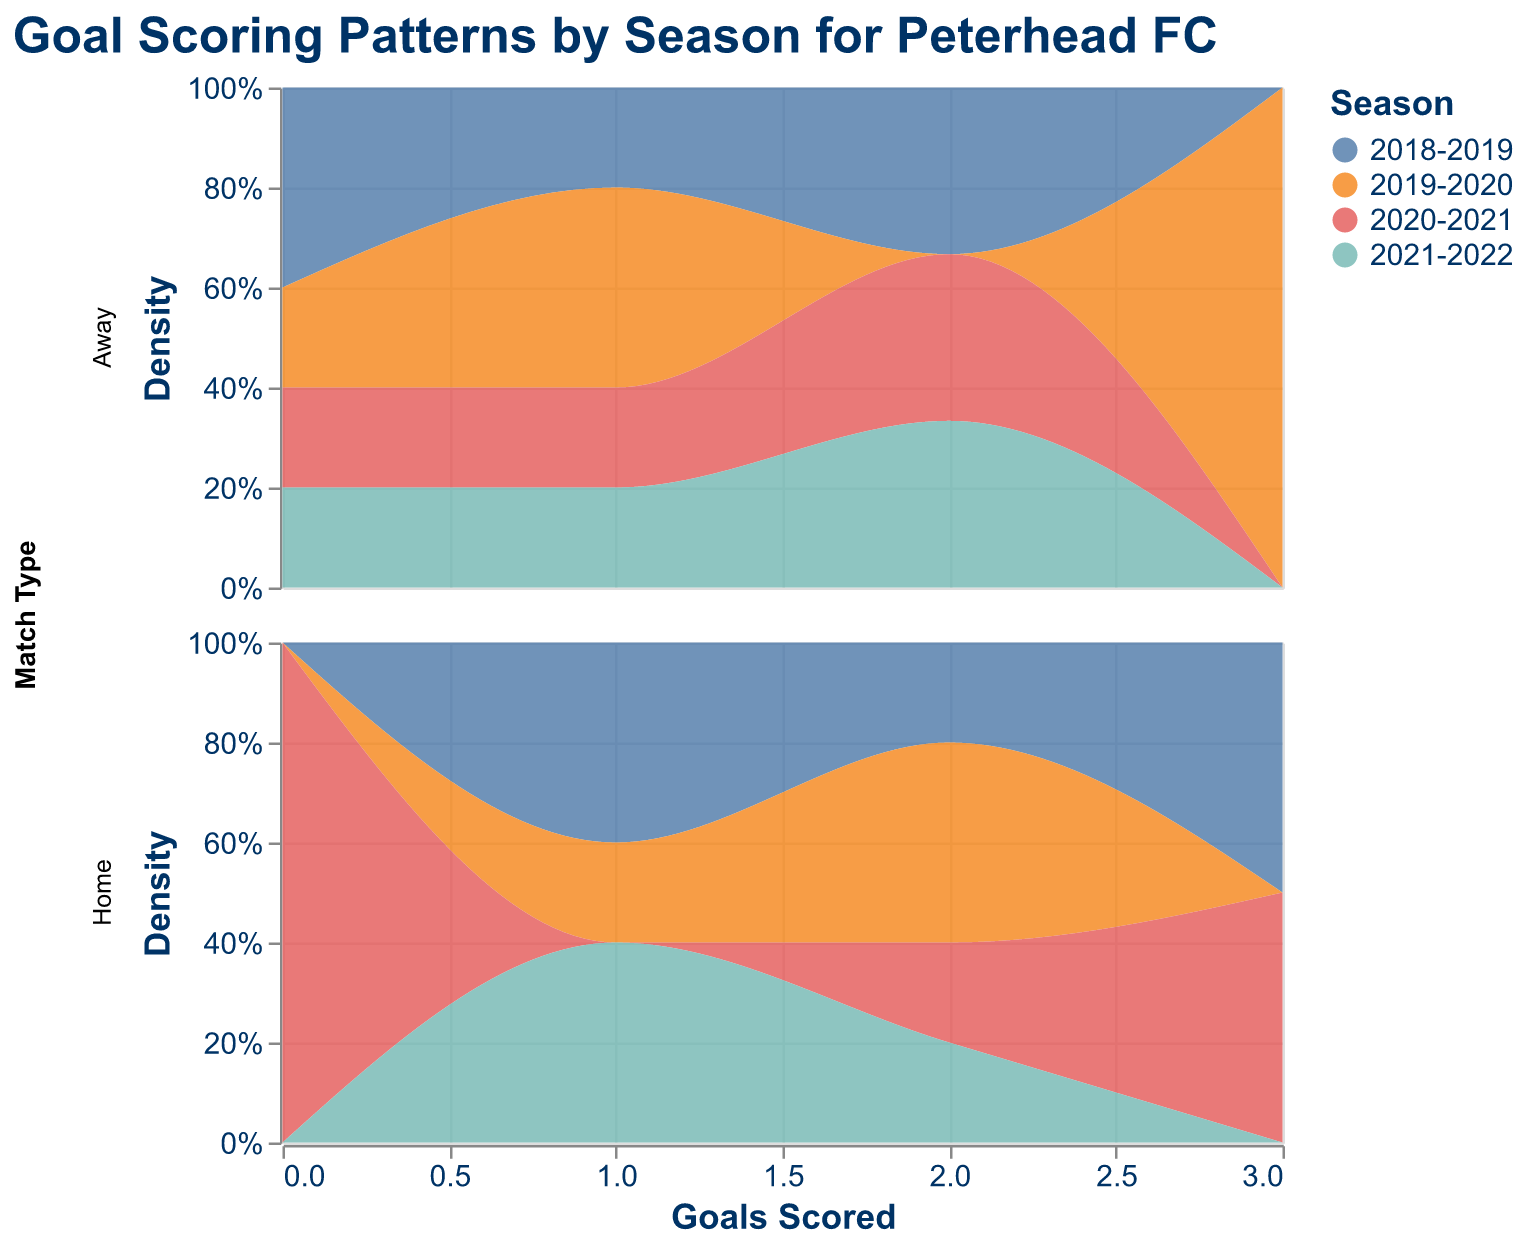How many seasons are represented in the figure? The legend in the figure shows different colors representing the seasons. Count the unique colors in the legend to determine the number of seasons.
Answer: 4 Which season scored the most goals at home? Examine the colors corresponding to the highest density peaks in the "Home" subplot. Determine which season's color has the highest peak on the "Goals Scored" axis.
Answer: 2018-2019 Are there more goals scored in home or away matches in the 2019-2020 season? Compare the areas under the curve for the season 2019-2020 in both Home and Away subplots. Determine which subplot has a larger area.
Answer: Home Which match type has a higher frequency of scoring 2 goals? In both "Home" and "Away" subplots, identify the peak heights at 2 goals. The subplot with the higher density at 2 goals indicates higher frequency.
Answer: Away What is the distribution of goals scored in away matches for the 2021-2022 season? Look at the density plot for "Away" matches and focus on the color representing the 2021-2022 season. Describe the distribution by noting the peaks and range of goals scored.
Answer: Peaks at 0, 1, and 2 goals Do home matches generally show a higher scoring pattern than away matches? Compare the overall density curves of the "Home" and "Away" subplots. Determine if the peak densities in home matches are generally higher than those in away matches.
Answer: Yes Did Peterhead FC have a season with no goals scored in away matches? Look at the density plot for "Away" matches and see if any season color shows a density peak at 0 goals and no other peaks.
Answer: No Which season has the most evenly distributed goal scoring pattern in home matches? Inspect the density curves for each season in the "Home" plot. The season with a more even distribution across multiple goal values and without sharp peaks is the answer.
Answer: 2021-2022 What is the most frequent number of goals scored in home matches during the 2020-2021 season? In the "Home" subplot, identify the highest peak for the color representing the 2020-2021 season on the "Goals Scored" axis.
Answer: 2 How does the density of scoring zero goals in away matches compare across different seasons? Examine the height of the peaks at 0 goals in the "Away" subplot across different seasons' colors. Compare the densities to see which season has a higher or lower frequency of scoring zero goals.
Answer: Similar across seasons 